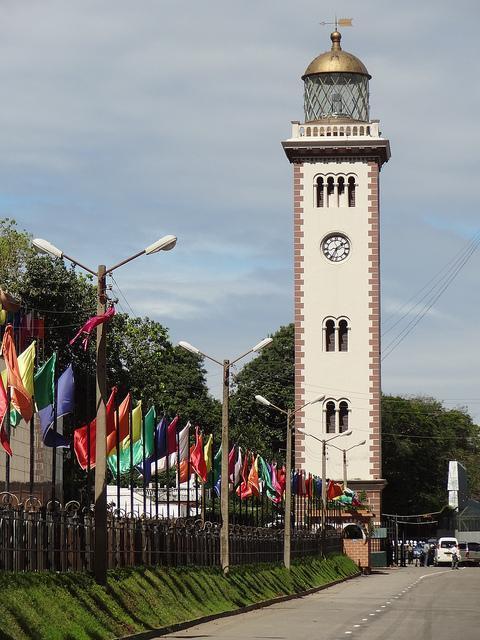How many rolls of toilet paper are on the toilet?
Give a very brief answer. 0. 